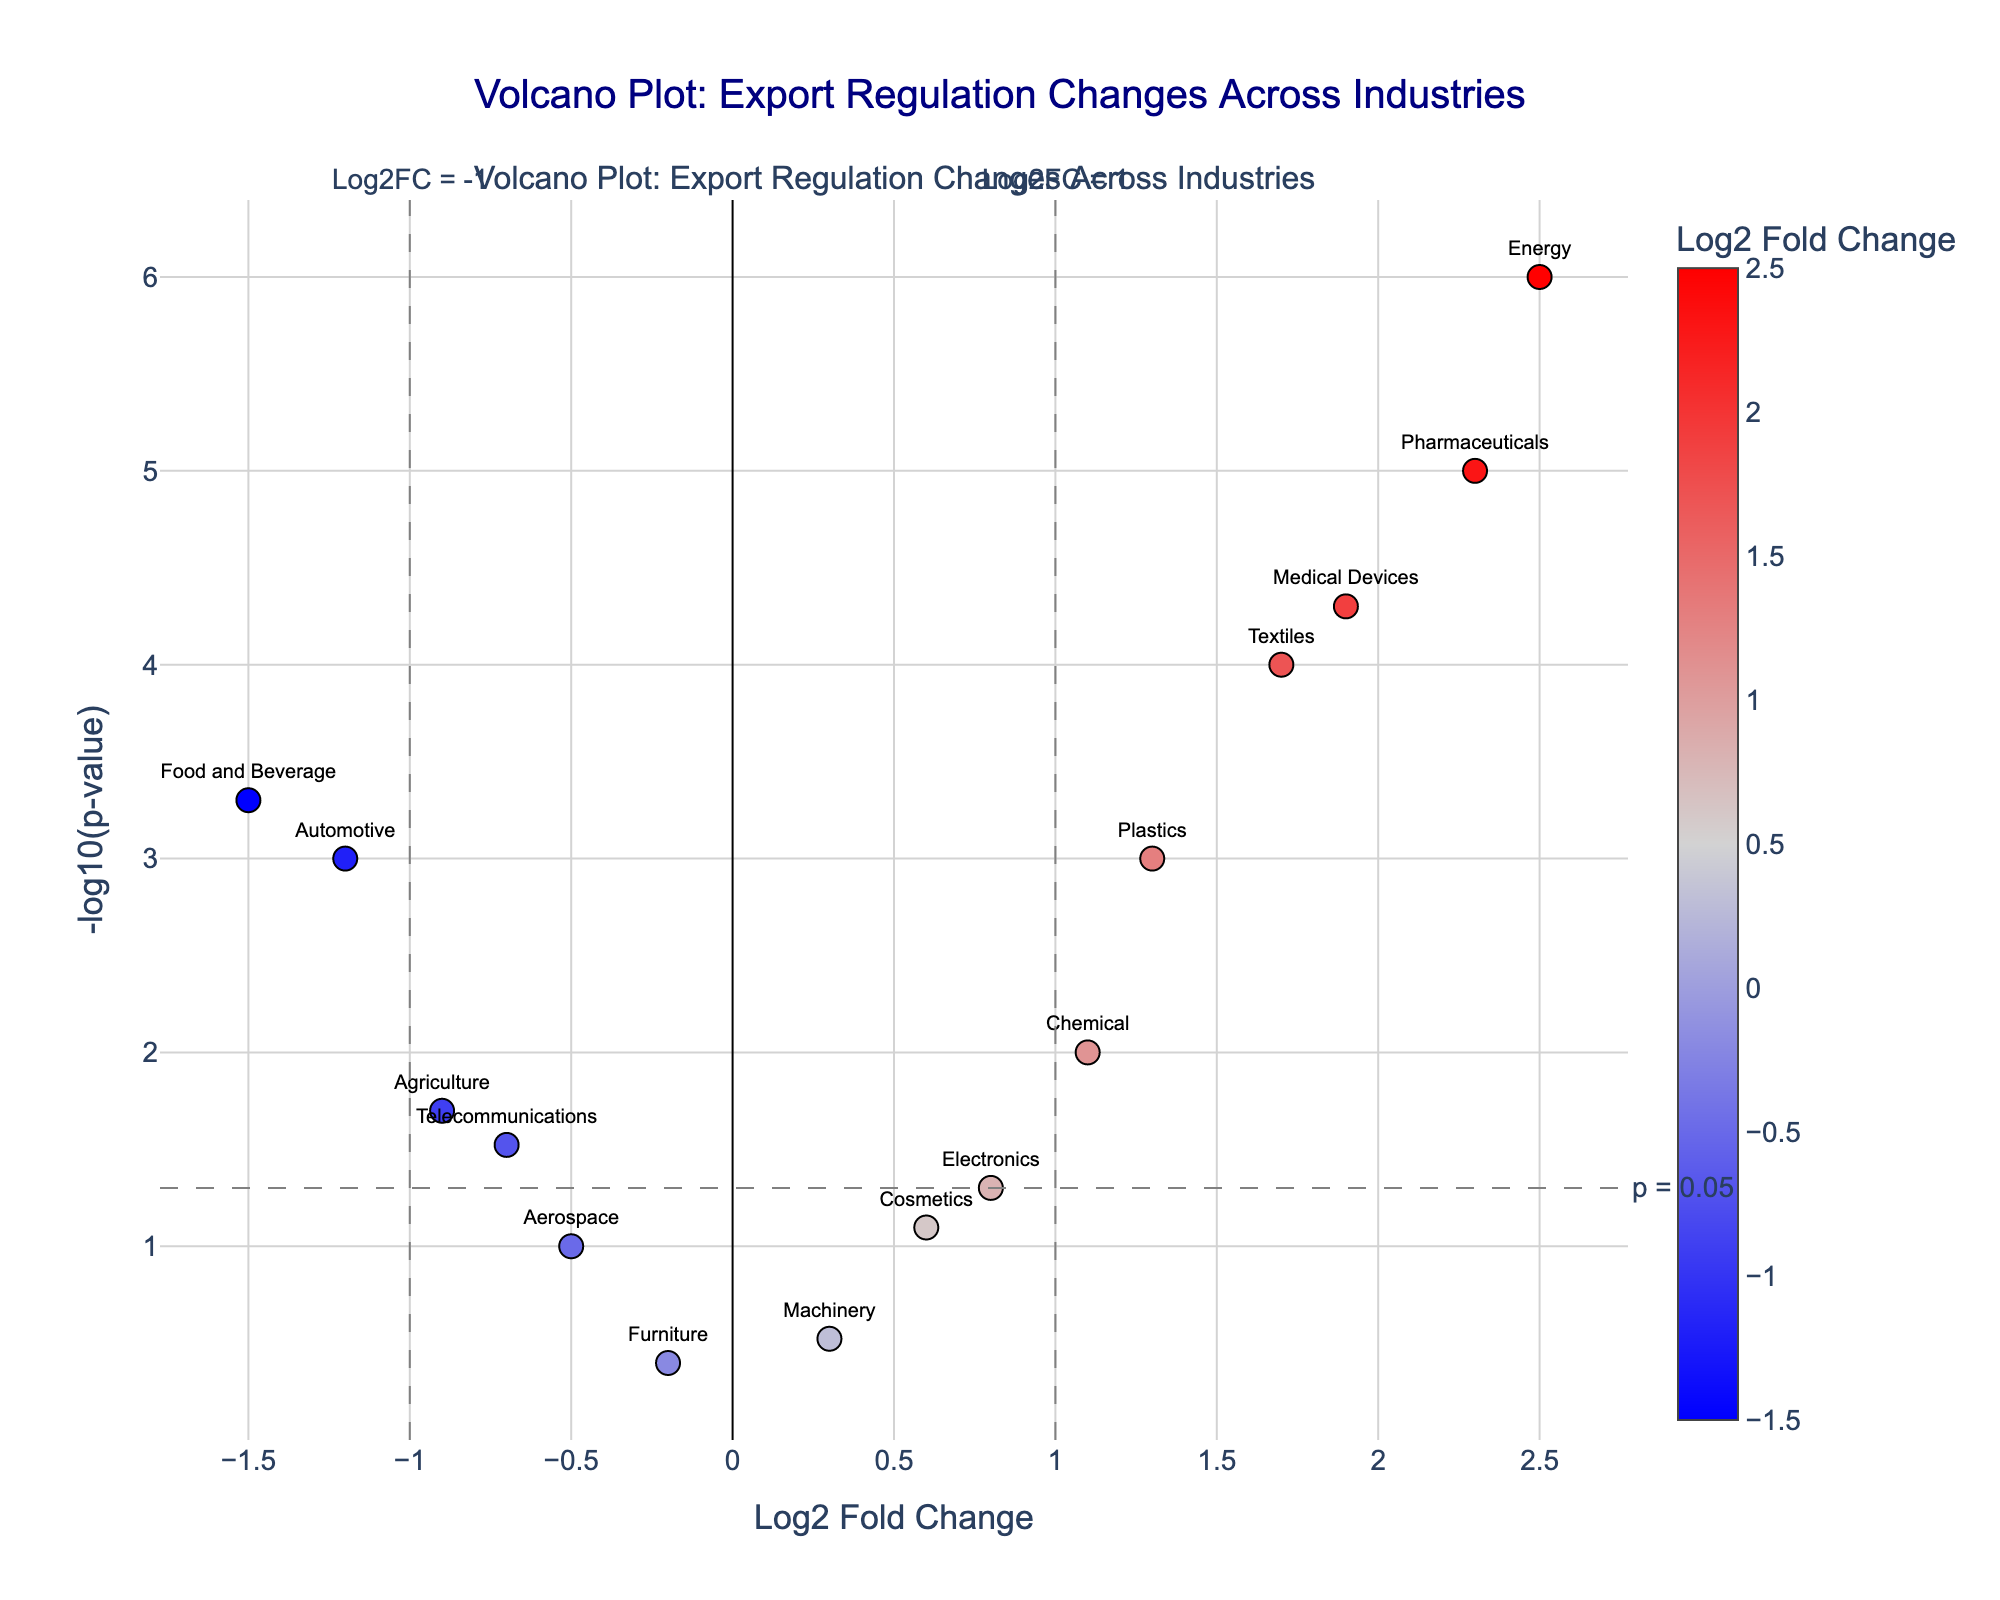What's the title of the plot? The title is written at the top of the figure and usually represents the main context of the data visualization. From the description, it is clear the title is "Volcano Plot: Export Regulation Changes Across Industries".
Answer: Volcano Plot: Export Regulation Changes Across Industries Which industries have a Log2 Fold Change greater than 2? To determine this, look for points on the plot where the x-axis value is greater than 2. From the data, we see that 'Energy' and 'Pharmaceuticals' have Log2 Fold Change values of 2.5 and 2.3 respectively.
Answer: Energy, Pharmaceuticals What does a high -log10(p-value) indicate about an industry? A high -log10(p-value) means a very low p-value, which in turn indicates that the change in export regulations for that industry is statistically significant. This is generally marked by points higher up on the y-axis.
Answer: High statistical significance Which industry experienced the most statistically significant positive change? Look for the point with the highest position along the y-axis and a positive value along the x-axis. From the data, Pharmaceuticals has the highest -log10(p-value) of 5 and a Log2 Fold Change of 2.3.
Answer: Pharmaceuticals Compare the statistical significance of the changes for the 'Automotive' and 'Textiles' industries. The statistical significance is represented by the -log10(p-value). Automotive has a -log10(p-value) of 3 (since PValue is 0.001) while Textiles has a -log10(p-value) of 4 (since PValue is 0.0001). Therefore, Textiles experienced a more statistically significant change than Automotive.
Answer: Textiles Which industry shows the least statistically significant change? The least statistically significant change corresponds to the point closest to the x-axis. From the data, 'Furniture' has the highest p-value of 0.4, which corresponds to the lowest -log10(p-value).
Answer: Furniture What is the Log2 Fold Change value for the 'Food and Beverage' industry, and what does it tell us about the export regulation change? The Log2 Fold Change value for 'Food and Beverage' is -1.5. A negative value means a decrease, thus it experienced a significant tightening of export regulations given the p-value is quite low (0.0005).
Answer: -1.5, significant tightening Is the change in export regulations for the 'Electronics' industry considered statistically significant? To determine significance, check if the point is above the horizontal line at -log10(0.05). 'Electronics' has a Log2 Fold Change of 0.8 and a p-value of 0.05, which translates to -log10(0.05) = 1. Because it is exactly on the threshold line, it is considered marginally significant.
Answer: Marginally significant How many industries exhibit a Log2 Fold Change between -1 and 1 and what does this range indicate? Count the points that fall between -1 and 1 on the x-axis. From the data, 'Electronics', 'Aerospace', 'Agriculture', 'Machinery', 'Cosmetics', 'Telecommunications', and 'Furniture' fall into this range. This range indicates more moderate changes in export regulations.
Answer: 7, moderate changes 